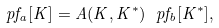<formula> <loc_0><loc_0><loc_500><loc_500>\ p f _ { a } [ K ] = A ( K , K ^ { * } ) \ p f _ { b } [ K ^ { * } ] ,</formula> 